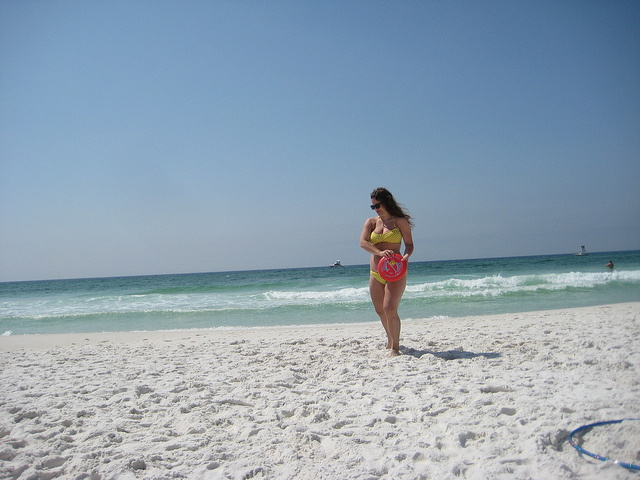How many people are walking on the beach? Based on the image, there is one person visible who appears to be walking on the beach. The individual seems to be enjoying a leisurely stroll along the shoreline, with the clear blue sky above and the pristine white sand beneath their feet. 